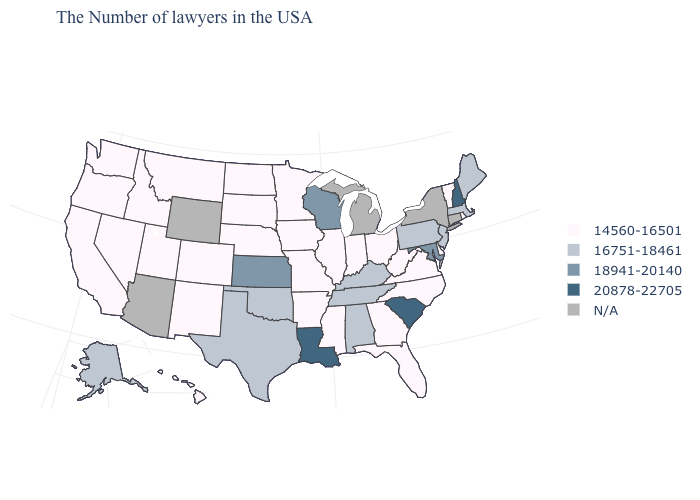Name the states that have a value in the range 14560-16501?
Keep it brief. Rhode Island, Vermont, Delaware, Virginia, North Carolina, West Virginia, Ohio, Florida, Georgia, Indiana, Illinois, Mississippi, Missouri, Arkansas, Minnesota, Iowa, Nebraska, South Dakota, North Dakota, Colorado, New Mexico, Utah, Montana, Idaho, Nevada, California, Washington, Oregon, Hawaii. What is the value of South Carolina?
Short answer required. 20878-22705. Which states have the lowest value in the South?
Short answer required. Delaware, Virginia, North Carolina, West Virginia, Florida, Georgia, Mississippi, Arkansas. Among the states that border California , which have the lowest value?
Be succinct. Nevada, Oregon. Does West Virginia have the highest value in the South?
Keep it brief. No. Name the states that have a value in the range 18941-20140?
Write a very short answer. Maryland, Wisconsin, Kansas. Among the states that border Wisconsin , which have the lowest value?
Give a very brief answer. Illinois, Minnesota, Iowa. Among the states that border Idaho , which have the lowest value?
Concise answer only. Utah, Montana, Nevada, Washington, Oregon. Does New Hampshire have the highest value in the Northeast?
Give a very brief answer. Yes. Name the states that have a value in the range 20878-22705?
Short answer required. New Hampshire, South Carolina, Louisiana. What is the lowest value in states that border North Dakota?
Quick response, please. 14560-16501. What is the value of Arizona?
Concise answer only. N/A. Does the first symbol in the legend represent the smallest category?
Quick response, please. Yes. What is the value of Michigan?
Give a very brief answer. N/A. What is the lowest value in the West?
Be succinct. 14560-16501. 